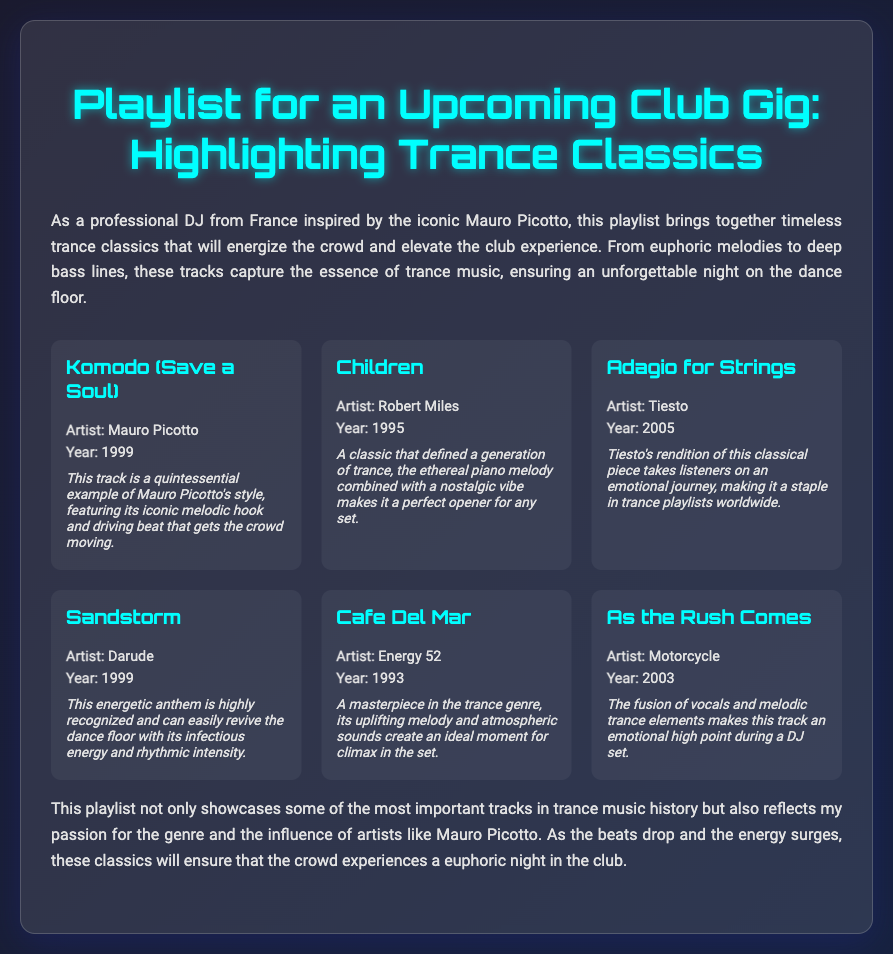What is the title of the playlist? The title of the playlist is found in the heading of the document.
Answer: Playlist for an Upcoming Club Gig: Highlighting Trance Classics Who is the artist of "Komodo (Save a Soul)"? This information is provided in the track details for "Komodo (Save a Soul)".
Answer: Mauro Picotto What year was "Children" released? The release year of "Children" is listed under the track details.
Answer: 1995 Which track is known for its emotional journey? The document states that "Adagio for Strings" takes listeners on an emotional journey.
Answer: Adagio for Strings What type of music is this playlist focused on? The introductory paragraph explains the focus of the playlist.
Answer: Trance How many tracks are listed in the playlist? The total number of tracks can be counted from the document.
Answer: 6 What is the main influence mentioned for the DJ? The introduction mentions a specific influence of the DJ's work.
Answer: Mauro Picotto What is the unique feature of "Café Del Mar" noted in the document? The note about "Café Del Mar" highlights its uplifting melody and atmospheric sounds.
Answer: Masterpiece in the trance genre 